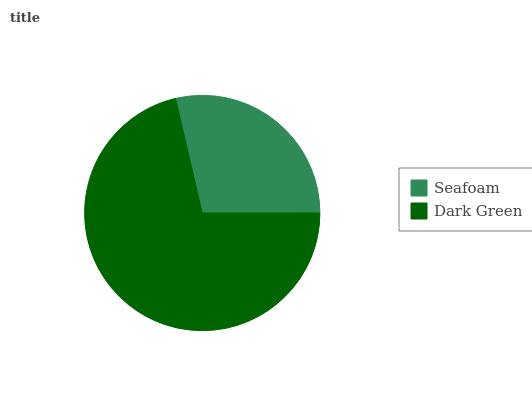Is Seafoam the minimum?
Answer yes or no. Yes. Is Dark Green the maximum?
Answer yes or no. Yes. Is Dark Green the minimum?
Answer yes or no. No. Is Dark Green greater than Seafoam?
Answer yes or no. Yes. Is Seafoam less than Dark Green?
Answer yes or no. Yes. Is Seafoam greater than Dark Green?
Answer yes or no. No. Is Dark Green less than Seafoam?
Answer yes or no. No. Is Dark Green the high median?
Answer yes or no. Yes. Is Seafoam the low median?
Answer yes or no. Yes. Is Seafoam the high median?
Answer yes or no. No. Is Dark Green the low median?
Answer yes or no. No. 